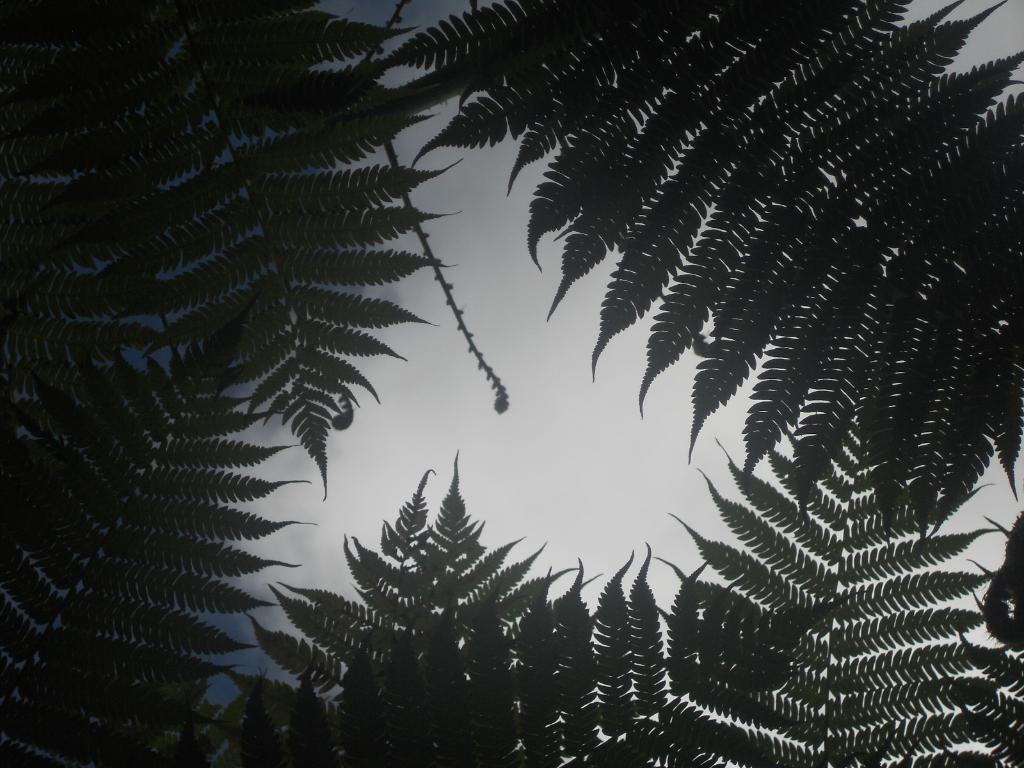What type of vegetation is visible in the image? There are leaves of a tree in the image. What is the condition of the sky in the image? The sky is cloudy in the image. How many dogs are participating in the action in the image? There are no dogs or any action involving dogs present in the image. What type of birthday celebration is depicted in the image? There is no birthday celebration depicted in the image; it features leaves of a tree and a cloudy sky. 